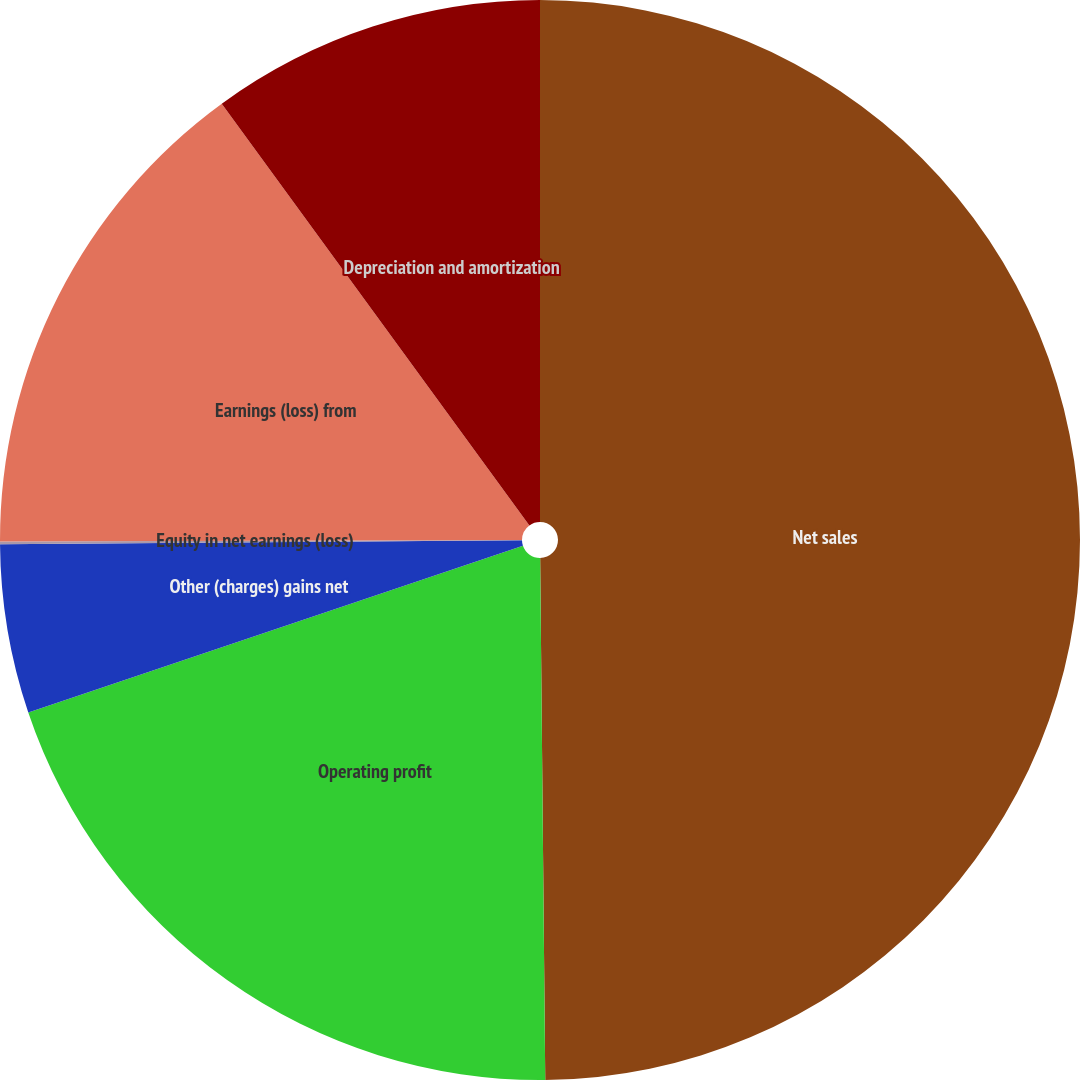Convert chart to OTSL. <chart><loc_0><loc_0><loc_500><loc_500><pie_chart><fcel>Net sales<fcel>Operating profit<fcel>Other (charges) gains net<fcel>Equity in net earnings (loss)<fcel>Earnings (loss) from<fcel>Depreciation and amortization<nl><fcel>49.84%<fcel>19.98%<fcel>5.05%<fcel>0.08%<fcel>15.01%<fcel>10.03%<nl></chart> 